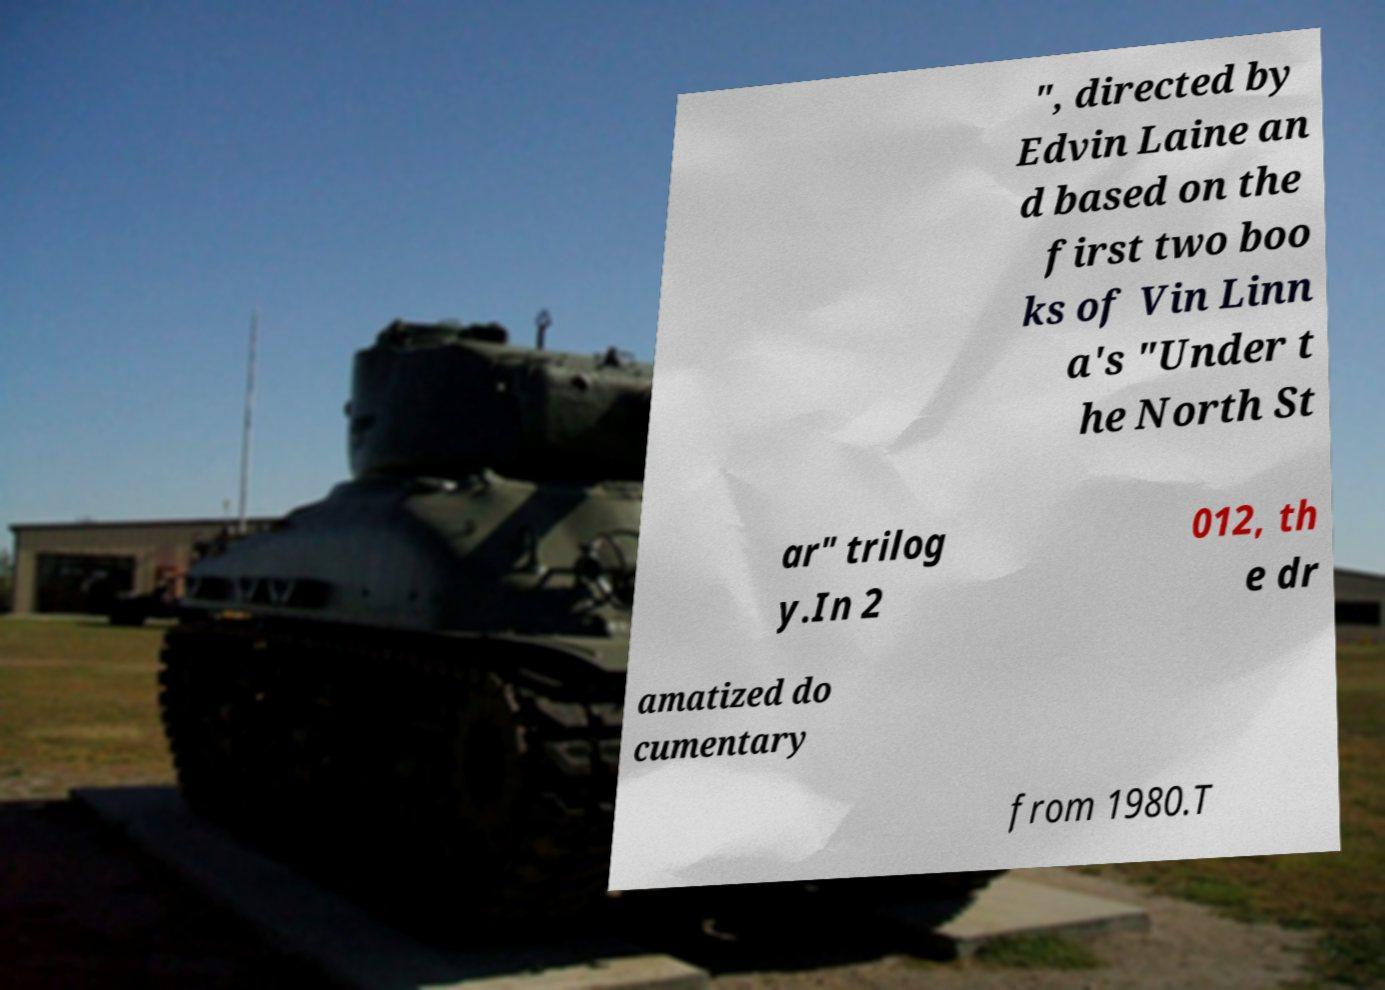I need the written content from this picture converted into text. Can you do that? ", directed by Edvin Laine an d based on the first two boo ks of Vin Linn a's "Under t he North St ar" trilog y.In 2 012, th e dr amatized do cumentary from 1980.T 